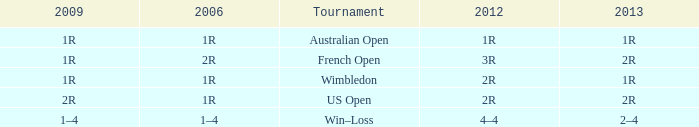What is the Tournament when the 2013 is 1r? Australian Open, Wimbledon. 